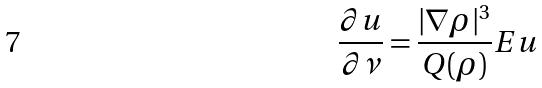<formula> <loc_0><loc_0><loc_500><loc_500>\frac { \partial u } { \partial \nu } = \frac { | \nabla \rho | ^ { 3 } } { Q ( \rho ) } E u</formula> 